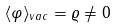<formula> <loc_0><loc_0><loc_500><loc_500>\langle \varphi \rangle _ { v a c } = \varrho \not = 0</formula> 